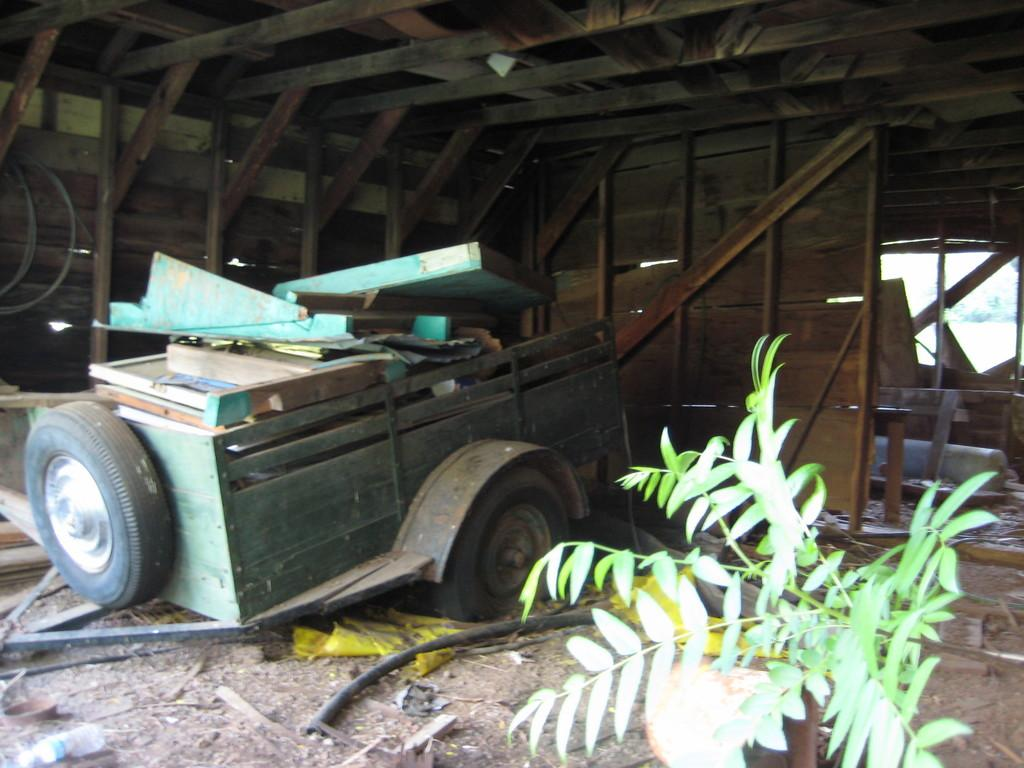What is the main subject in the center of the image? There is a vehicle in the center of the image. What is the position of the vehicle in the image? The vehicle is on the ground. What material can be found inside the vehicle? There is wood in the vehicle. What can be seen in the background of the image? There is a wooden wall in the background of the image. What type of vegetation is on the right side of the image? There is a plant on the right side of the image. What type of vase is holding the sticks in the image? There is no vase or sticks present in the image. 